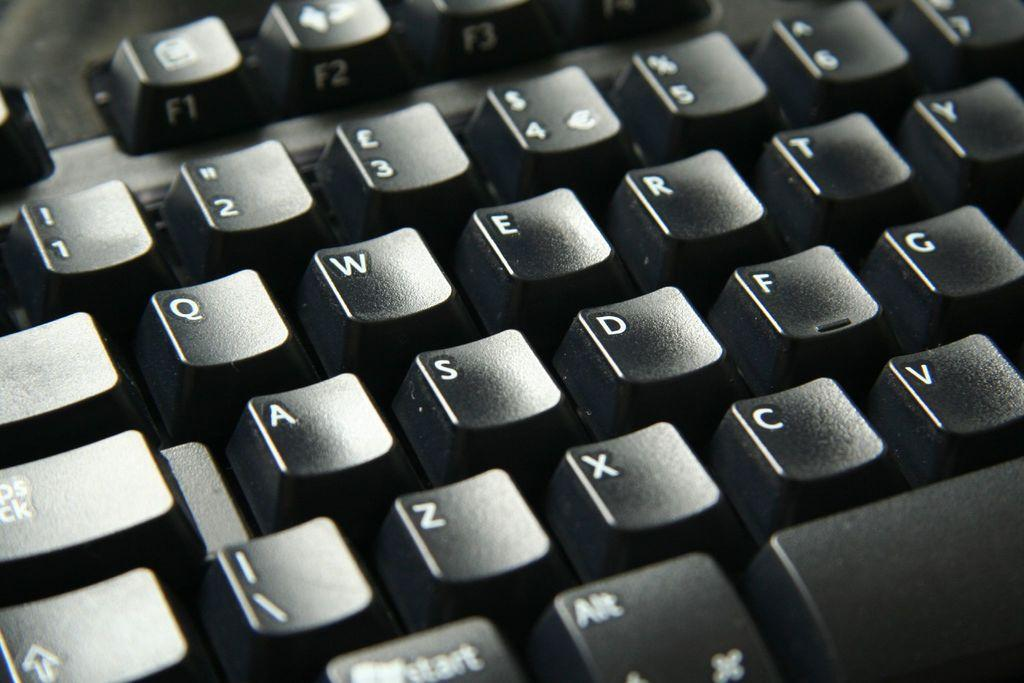<image>
Give a short and clear explanation of the subsequent image. A black keyboard with the caps lock key and qwerty showing. 